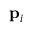Convert formula to latex. <formula><loc_0><loc_0><loc_500><loc_500>p _ { i }</formula> 